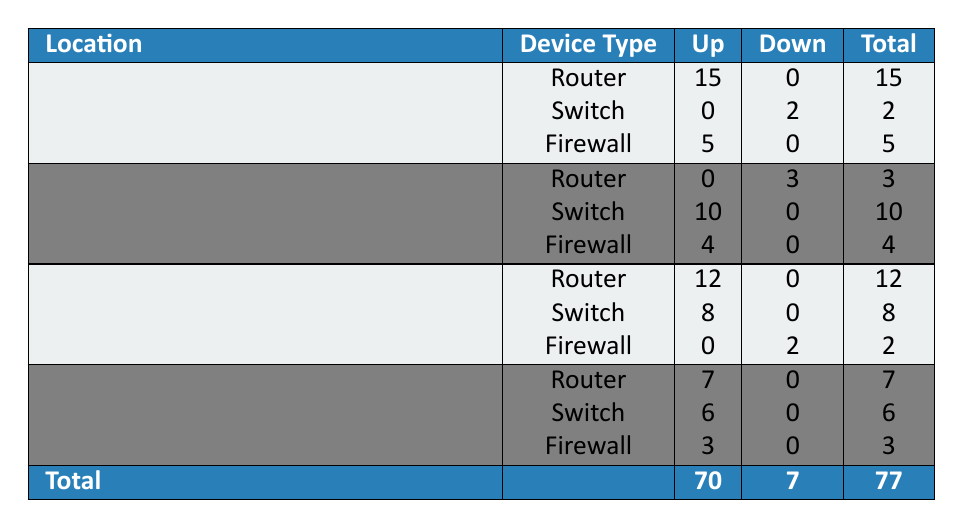What is the total number of devices in the New York Office? In the New York Office, the total number of devices is calculated by summing the counts of all device types listed, which are 15 (Router) + 2 (Switch) + 5 (Firewall) = 22.
Answer: 22 How many Firewalls are there in the Chicago Office? The Chicago Office has one entry for Firewalls, and the count is 2, meaning there are 2 Firewalls.
Answer: 2 Which location has the highest number of 'Up' statuses? To find the location with the highest number of 'Up' statuses, we sum the counts for devices that are 'Up' in each location: New York (15 + 5 = 20), San Francisco (10 + 4 = 14), Chicago (12 + 8 = 20), Seattle (7 + 6 + 3 = 16). New York and Chicago both have the highest count of 'Up' statuses, which is 20.
Answer: New York Office and Chicago Office Is there any Switch in the San Francisco Branch that is 'Down'? By reviewing the data, in the San Francisco Branch, the only Switch status is 'Up' with a count of 10, indicating that there are no 'Down' Switches in this branch.
Answer: No What is the difference in the number of 'Up' devices between the Seattle Branch and the New York Office? First, sum the 'Up' devices: Seattle (7 + 6 + 3 = 16), and New York (15 + 5 + 0 = 20). The difference is calculated as 20 - 16 = 4.
Answer: 4 How many totals devices are 'Down' in the entire dataset? To find the total 'Down' devices, we look at each location: New York (2), San Francisco (3), Chicago (2), Seattle (0). Adding these together gives: 2 + 3 + 2 + 0 = 7.
Answer: 7 Are there more 'Up' Routers or 'Up' Switches across all locations? Count the 'Up' Routers: New York (15), San Francisco (0), Chicago (12), Seattle (7). Total 'Up' Routers = 15 + 0 + 12 + 7 = 34. Count the 'Up' Switches: New York (0), San Francisco (10), Chicago (8), Seattle (6). Total 'Up' Switches = 0 + 10 + 8 + 6 = 24. Since 34 > 24, there are more 'Up' Routers.
Answer: Yes What percentage of devices in the Chicago Office are currently 'Down'? In the Chicago Office, there are a total of 12 (Router) + 8 (Switch) + 2 (Firewall) = 22 devices and 2 of them are 'Down' (the Firewall). The percentage is calculated as (2/22) * 100 = 9.09%.
Answer: 9.09% Which device type has the least number of 'Up' statuses in the table? Reviewing the table, the least number of 'Up' statuses comes from Firewall counts: New York (5), San Francisco (4), Chicago (0), Seattle (3). The least is 0 from Chicago's Firewall.
Answer: Firewall 